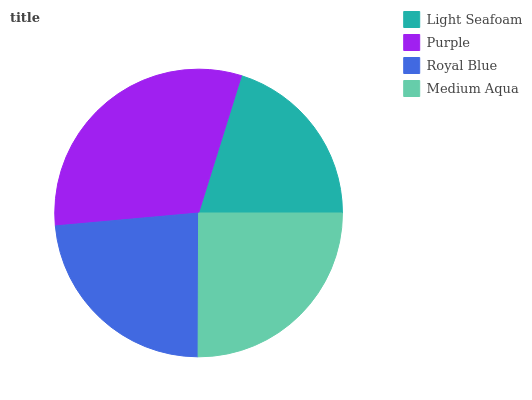Is Light Seafoam the minimum?
Answer yes or no. Yes. Is Purple the maximum?
Answer yes or no. Yes. Is Royal Blue the minimum?
Answer yes or no. No. Is Royal Blue the maximum?
Answer yes or no. No. Is Purple greater than Royal Blue?
Answer yes or no. Yes. Is Royal Blue less than Purple?
Answer yes or no. Yes. Is Royal Blue greater than Purple?
Answer yes or no. No. Is Purple less than Royal Blue?
Answer yes or no. No. Is Medium Aqua the high median?
Answer yes or no. Yes. Is Royal Blue the low median?
Answer yes or no. Yes. Is Purple the high median?
Answer yes or no. No. Is Light Seafoam the low median?
Answer yes or no. No. 